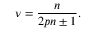Convert formula to latex. <formula><loc_0><loc_0><loc_500><loc_500>\nu = { \frac { n } { 2 p n \pm 1 } } .</formula> 